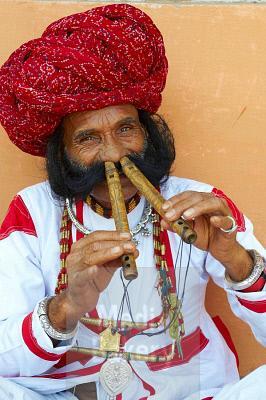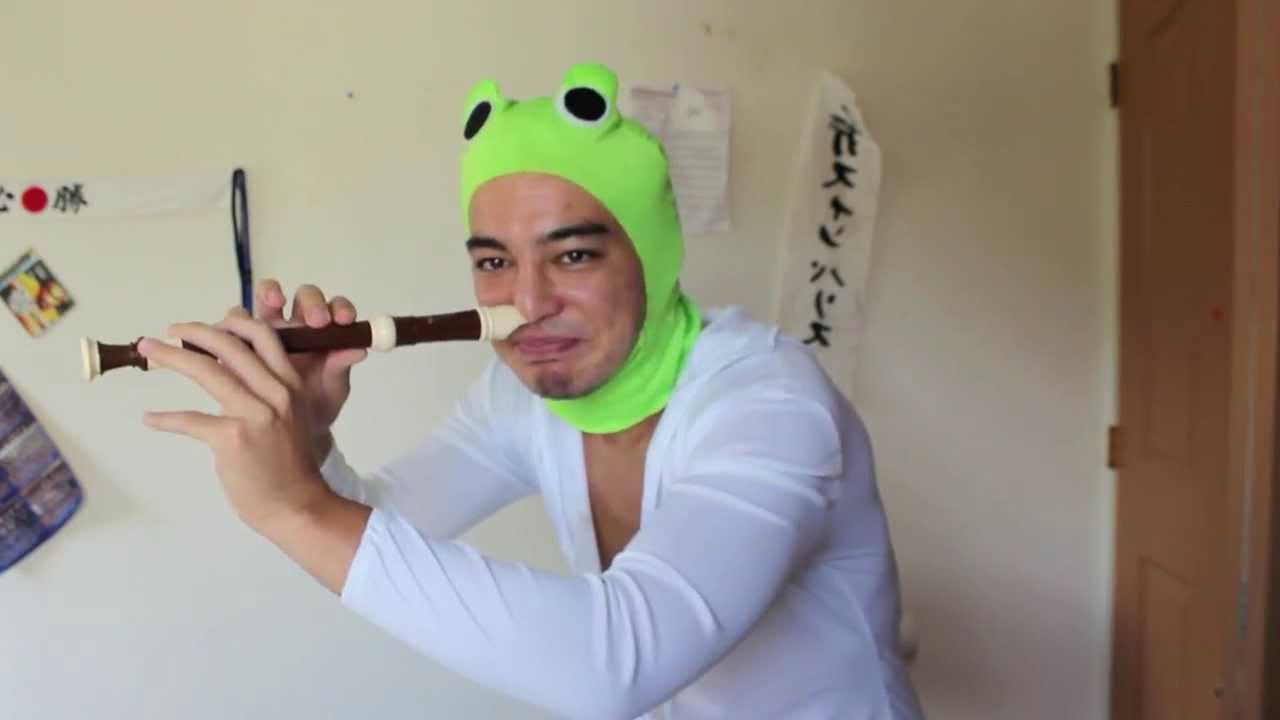The first image is the image on the left, the second image is the image on the right. Analyze the images presented: Is the assertion "There is a man playing two nose flutes in each image" valid? Answer yes or no. No. The first image is the image on the left, the second image is the image on the right. Considering the images on both sides, is "Each image shows a man holding at least one flute to a nostril, but only the left image features a man in a red turban and bushy dark facial hair holding two flutes to his nostrils." valid? Answer yes or no. Yes. 